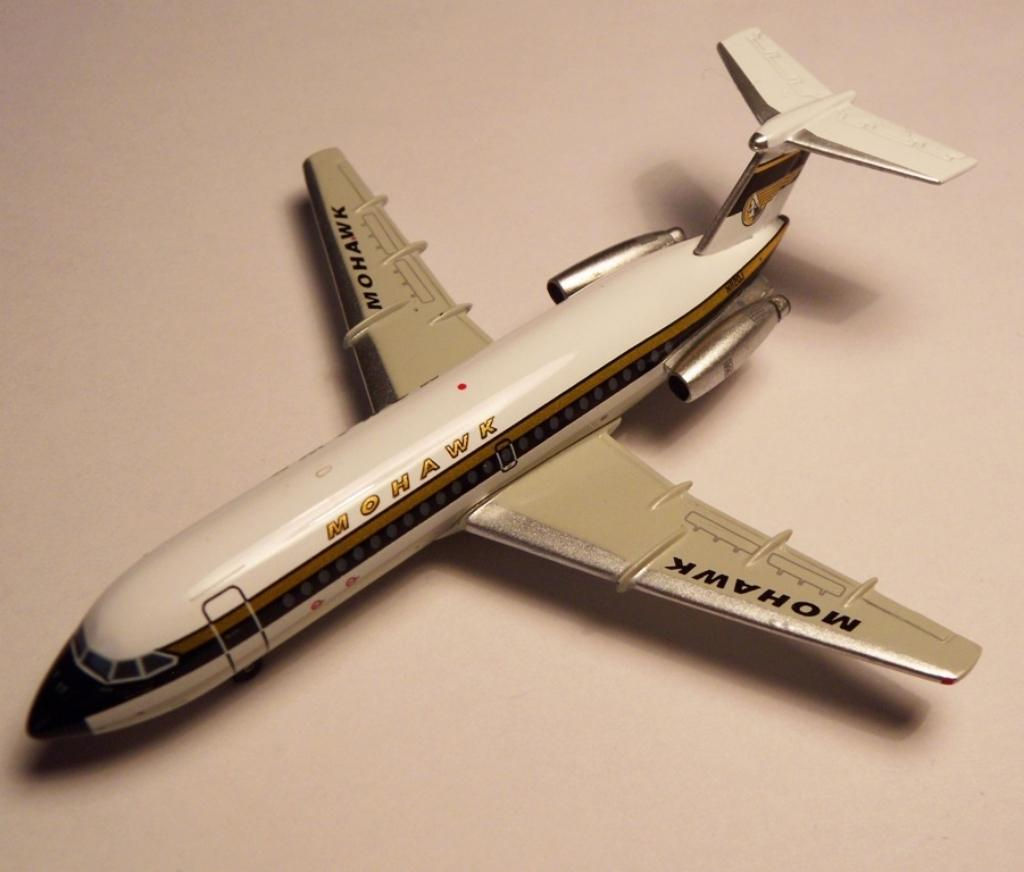What is the main object in the image? There is an aeroplane toy in the image. Where is the aeroplane toy located? The aeroplane toy is on a table. What type of gun is being used by the aeroplane toy in the image? There is no gun present in the image; it is an aeroplane toy on a table. 